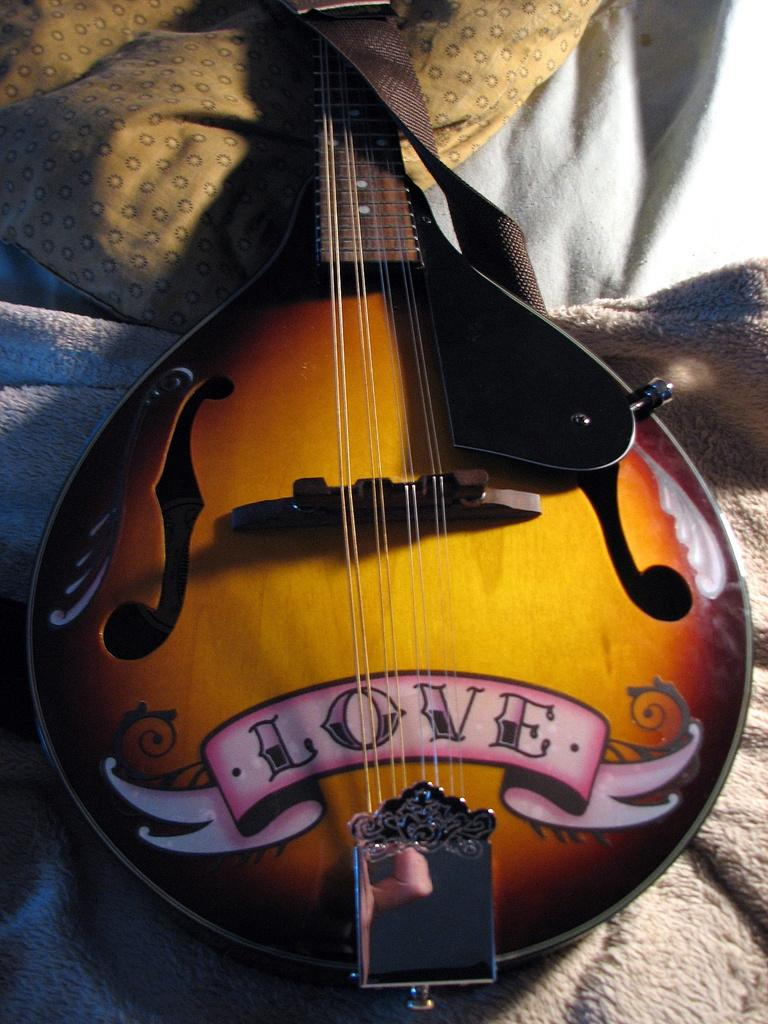What is the main object in the image? There is a guitar in the image. Where is the guitar located in the image? The guitar is in the middle of the image. What is the color of the guitar? The guitar is yellow in color. Are there any other yellow objects in the image? Yes, there is a yellow color bag in the image. Can you hear the cattle mooing in the image? There are no cattle present in the image, so it is not possible to hear them mooing. 